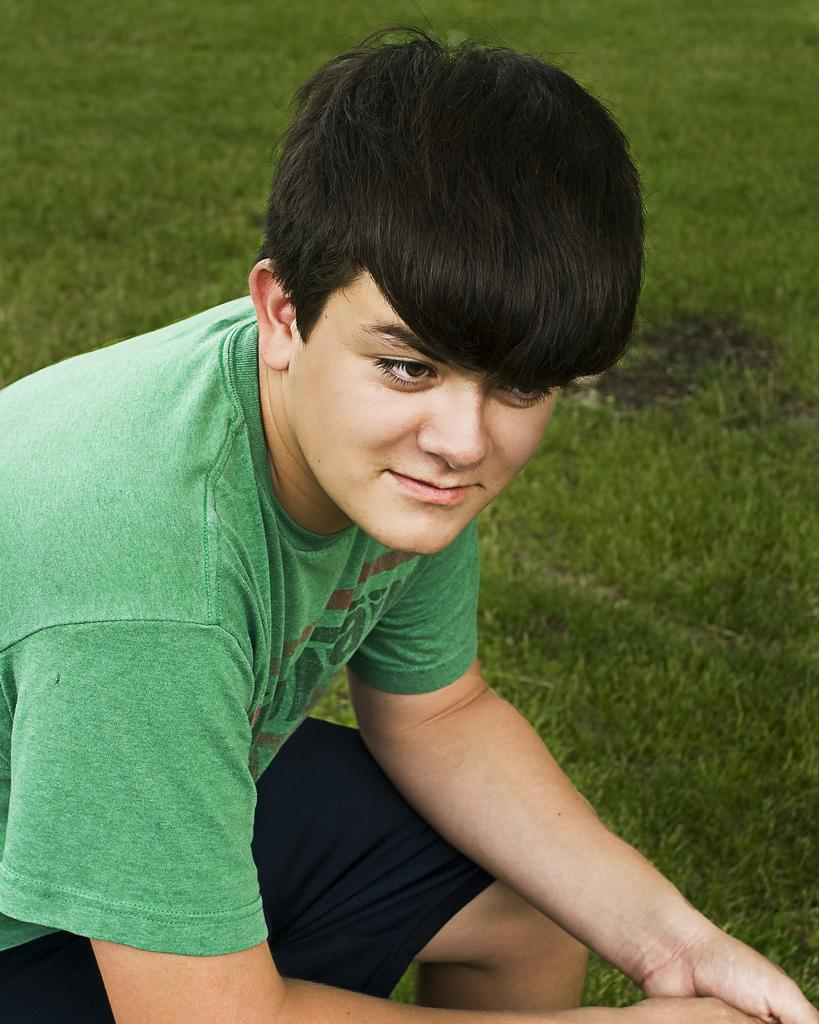Where was the image taken? The image was taken outdoors. What can be seen in the background of the image? There is a ground with grass in the background. What is the position of the boy in the image? The boy is on the left side of the image and is sitting. What type of gun is the boy holding in the image? There is no gun present in the image; the boy is sitting and not holding any object. 